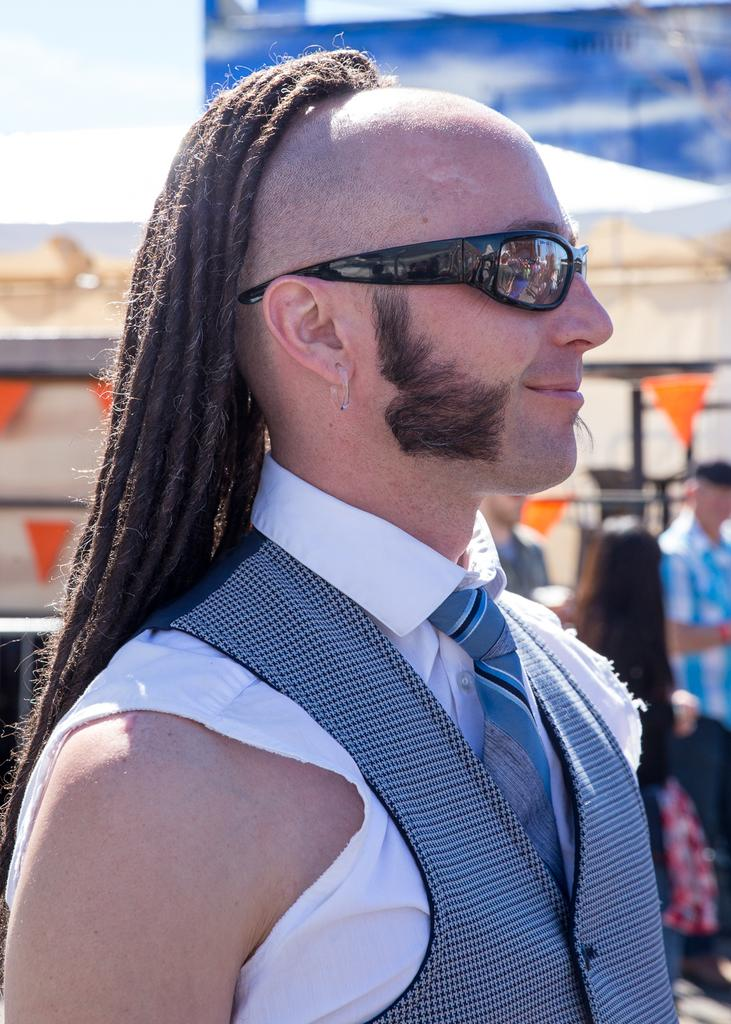How many people are in the image? There are people in the image, but the exact number is not specified. Can you describe any specific features of one of the people? Yes, one person is wearing spectacles. What can be seen in the background of the image? There is a background with objects visible in the image. What part of the natural environment is visible in the image? The sky is visible in the image. What type of guitar is the person playing in the image? There is no guitar present in the image. What scientific discovery is being discussed by the people in the image? There is no indication of a scientific discussion or discovery in the image. 